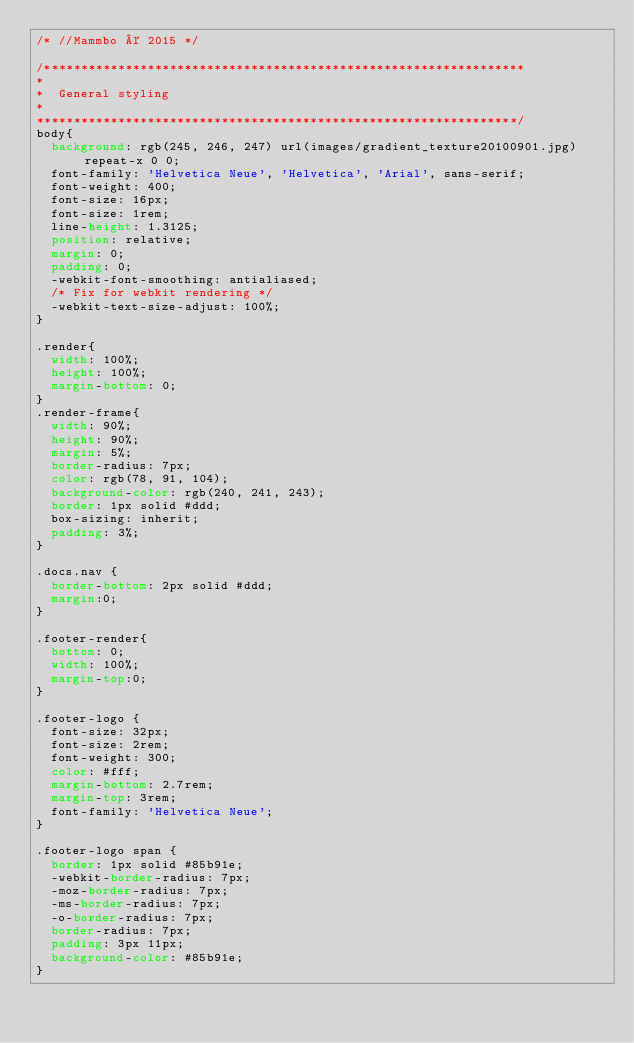Convert code to text. <code><loc_0><loc_0><loc_500><loc_500><_CSS_>/* //Mammbo © 2015 */

/***************************************************************** 
*
*  General styling
*
*****************************************************************/
body{
  background: rgb(245, 246, 247) url(images/gradient_texture20100901.jpg) repeat-x 0 0;
  font-family: 'Helvetica Neue', 'Helvetica', 'Arial', sans-serif;
  font-weight: 400;
  font-size: 16px;
  font-size: 1rem;
  line-height: 1.3125;
  position: relative;
  margin: 0;
  padding: 0;
  -webkit-font-smoothing: antialiased;
  /* Fix for webkit rendering */
  -webkit-text-size-adjust: 100%;
}

.render{
  width: 100%;
  height: 100%;
  margin-bottom: 0;
}
.render-frame{
  width: 90%;
  height: 90%;
  margin: 5%;
  border-radius: 7px;
  color: rgb(78, 91, 104);
  background-color: rgb(240, 241, 243);
  border: 1px solid #ddd;
  box-sizing: inherit;
  padding: 3%;
}

.docs.nav {
  border-bottom: 2px solid #ddd;
  margin:0;
}

.footer-render{
  bottom: 0;
  width: 100%;
  margin-top:0;
}

.footer-logo {
  font-size: 32px;
  font-size: 2rem;
  font-weight: 300;
  color: #fff;
  margin-bottom: 2.7rem;
  margin-top: 3rem;
  font-family: 'Helvetica Neue';
}

.footer-logo span {
  border: 1px solid #85b91e;
  -webkit-border-radius: 7px;
  -moz-border-radius: 7px;
  -ms-border-radius: 7px;
  -o-border-radius: 7px;
  border-radius: 7px;
  padding: 3px 11px;
  background-color: #85b91e;
}

</code> 